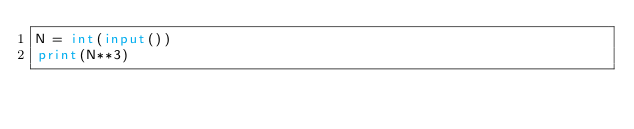<code> <loc_0><loc_0><loc_500><loc_500><_Python_>N = int(input())
print(N**3)
</code> 